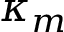<formula> <loc_0><loc_0><loc_500><loc_500>\kappa _ { m }</formula> 